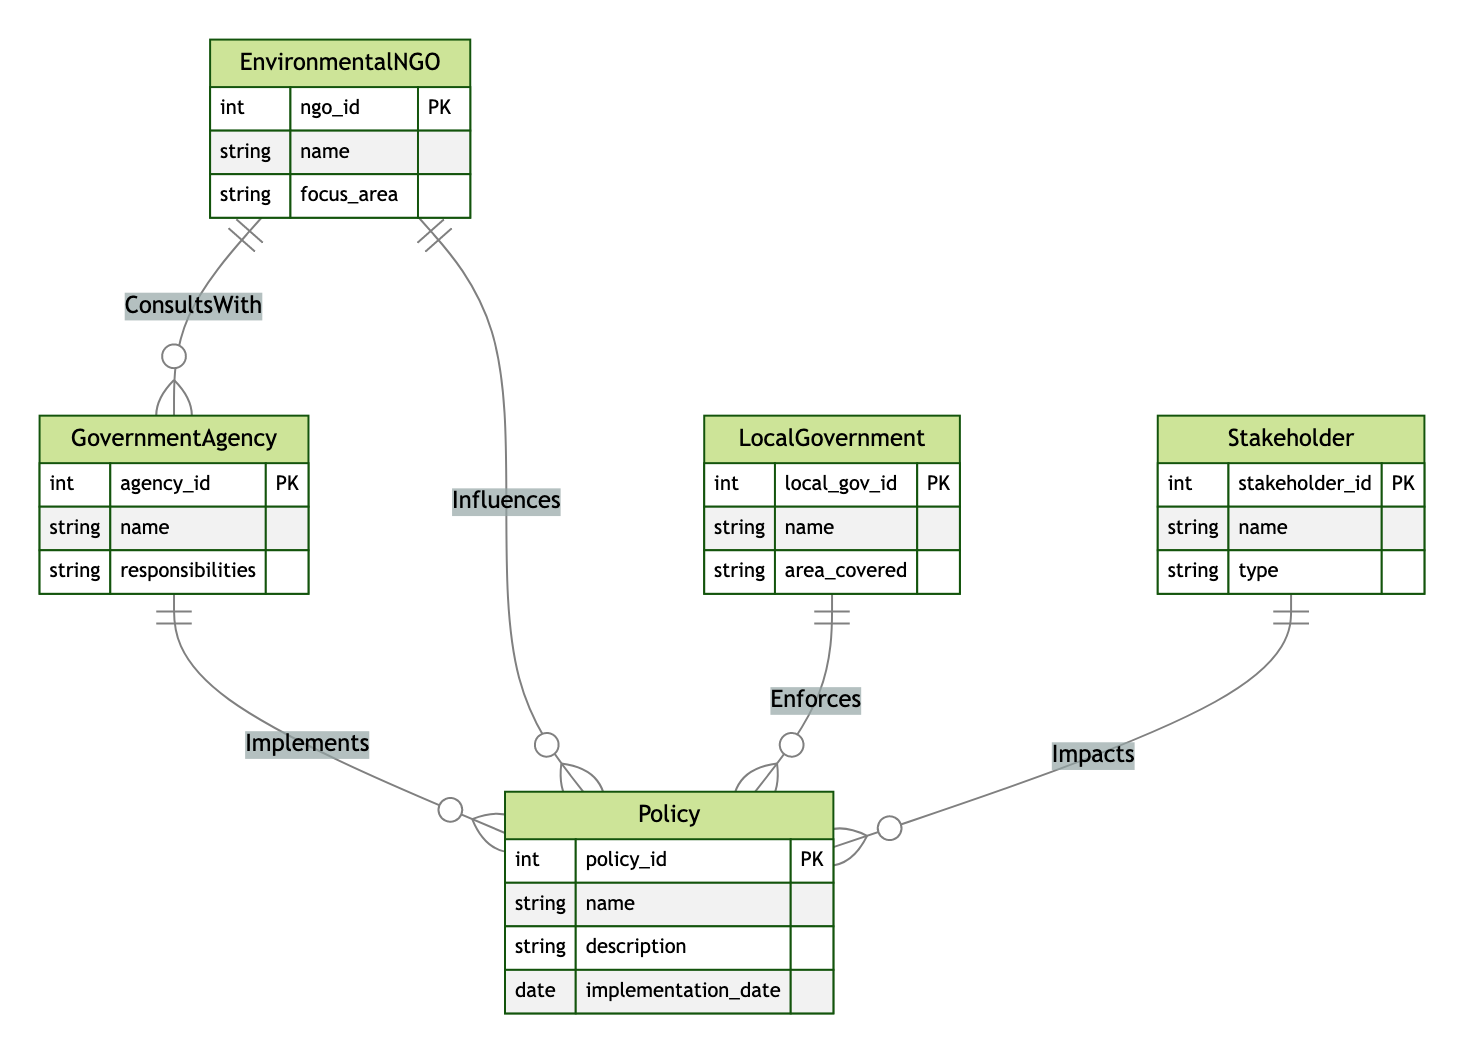What are the entities represented in the diagram? The diagram includes five entities: GovernmentAgency, EnvironmentalNGO, LocalGovernment, Policy, and Stakeholder. They are the main components represented within the Entity Relationship Diagram.
Answer: GovernmentAgency, EnvironmentalNGO, LocalGovernment, Policy, Stakeholder How many relationships are present in the diagram? The diagram shows a total of five relationships: Implements, Influences, Enforces, ConsultsWith, and Impacts. Each of these indicates how different entities interact with one another in the context of environmental policy.
Answer: 5 Which entity implements the policy? The relationship named "Implements" connects GovernmentAgency and Policy, indicating that GovernmentAgencies are responsible for implementing policies related to environmental matters in Victoria.
Answer: GovernmentAgency What type of relationship exists between EnvironmentalNGO and GovernmentAgency? The diagram features a "ConsultsWith" relationship between EnvironmentalNGO and GovernmentAgency. This shows that these entities engage in consultations as part of their interaction in the environmental policy landscape.
Answer: ConsultsWith Which entity enforces the policy? The relationship titled "Enforces" connects LocalGovernment and Policy. This indicates that Local Governments are tasked with enforcing the policies that are implemented.
Answer: LocalGovernment How many types of stakeholders are represented? The diagram identifies a single entity named Stakeholder, which can encompass various types; however, the diagram does not specify distinct types beyond what is represented in the Stakeholder entity. Thus, there is one general type.
Answer: 1 What is the focus area of EnvironmentalNGO? The diagram specifies that EnvironmentalNGOs have a focus_area attribute, allowing them to focus on various aspects of environmental protection and advocacy, although the diagram does not provide the specific focus areas for individual NGOs.
Answer: focus_area Which entity influences the policy? The relationship named "Influences" connects EnvironmentalNGO and Policy. This indicates that Environmental NGOs play a role in shaping or influencing policy decisions regarding environmental matters.
Answer: EnvironmentalNGO How are stakeholders related to policies in the diagram? The relationship named "Impacts" connects Stakeholder and Policy, illustrating that stakeholders have an impact on environmental policies, affecting how they are shaped or implemented.
Answer: Impacts 